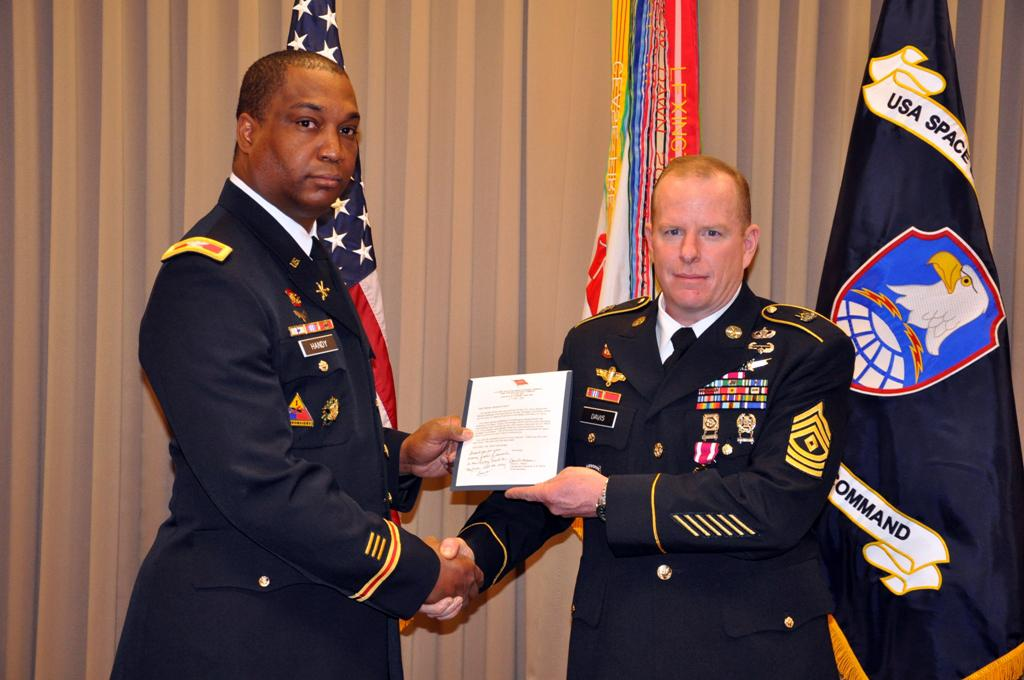<image>
Share a concise interpretation of the image provided. Two men shake hands in front of two flags, one of which has the word USA Space on the  top left 